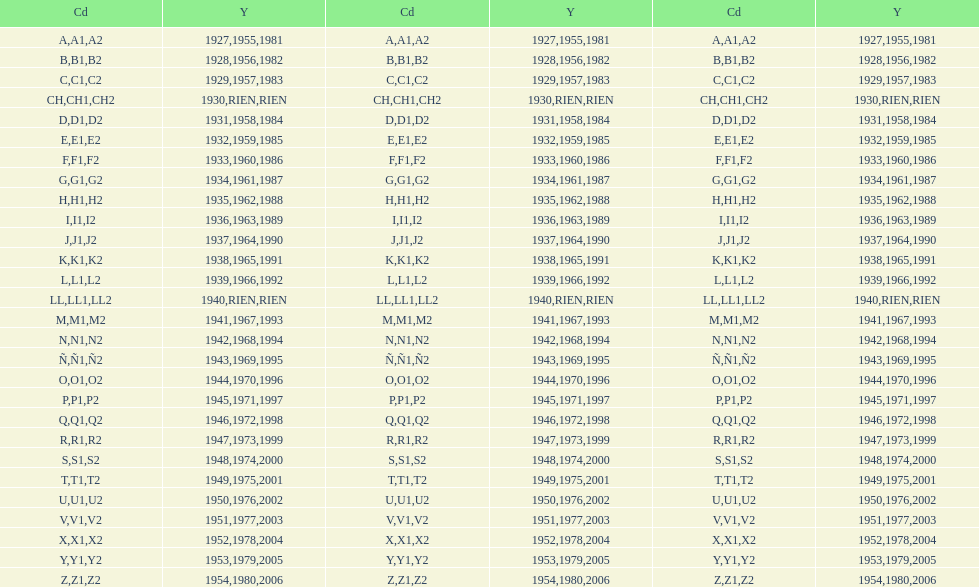What was the lowest year stamped? 1927. 